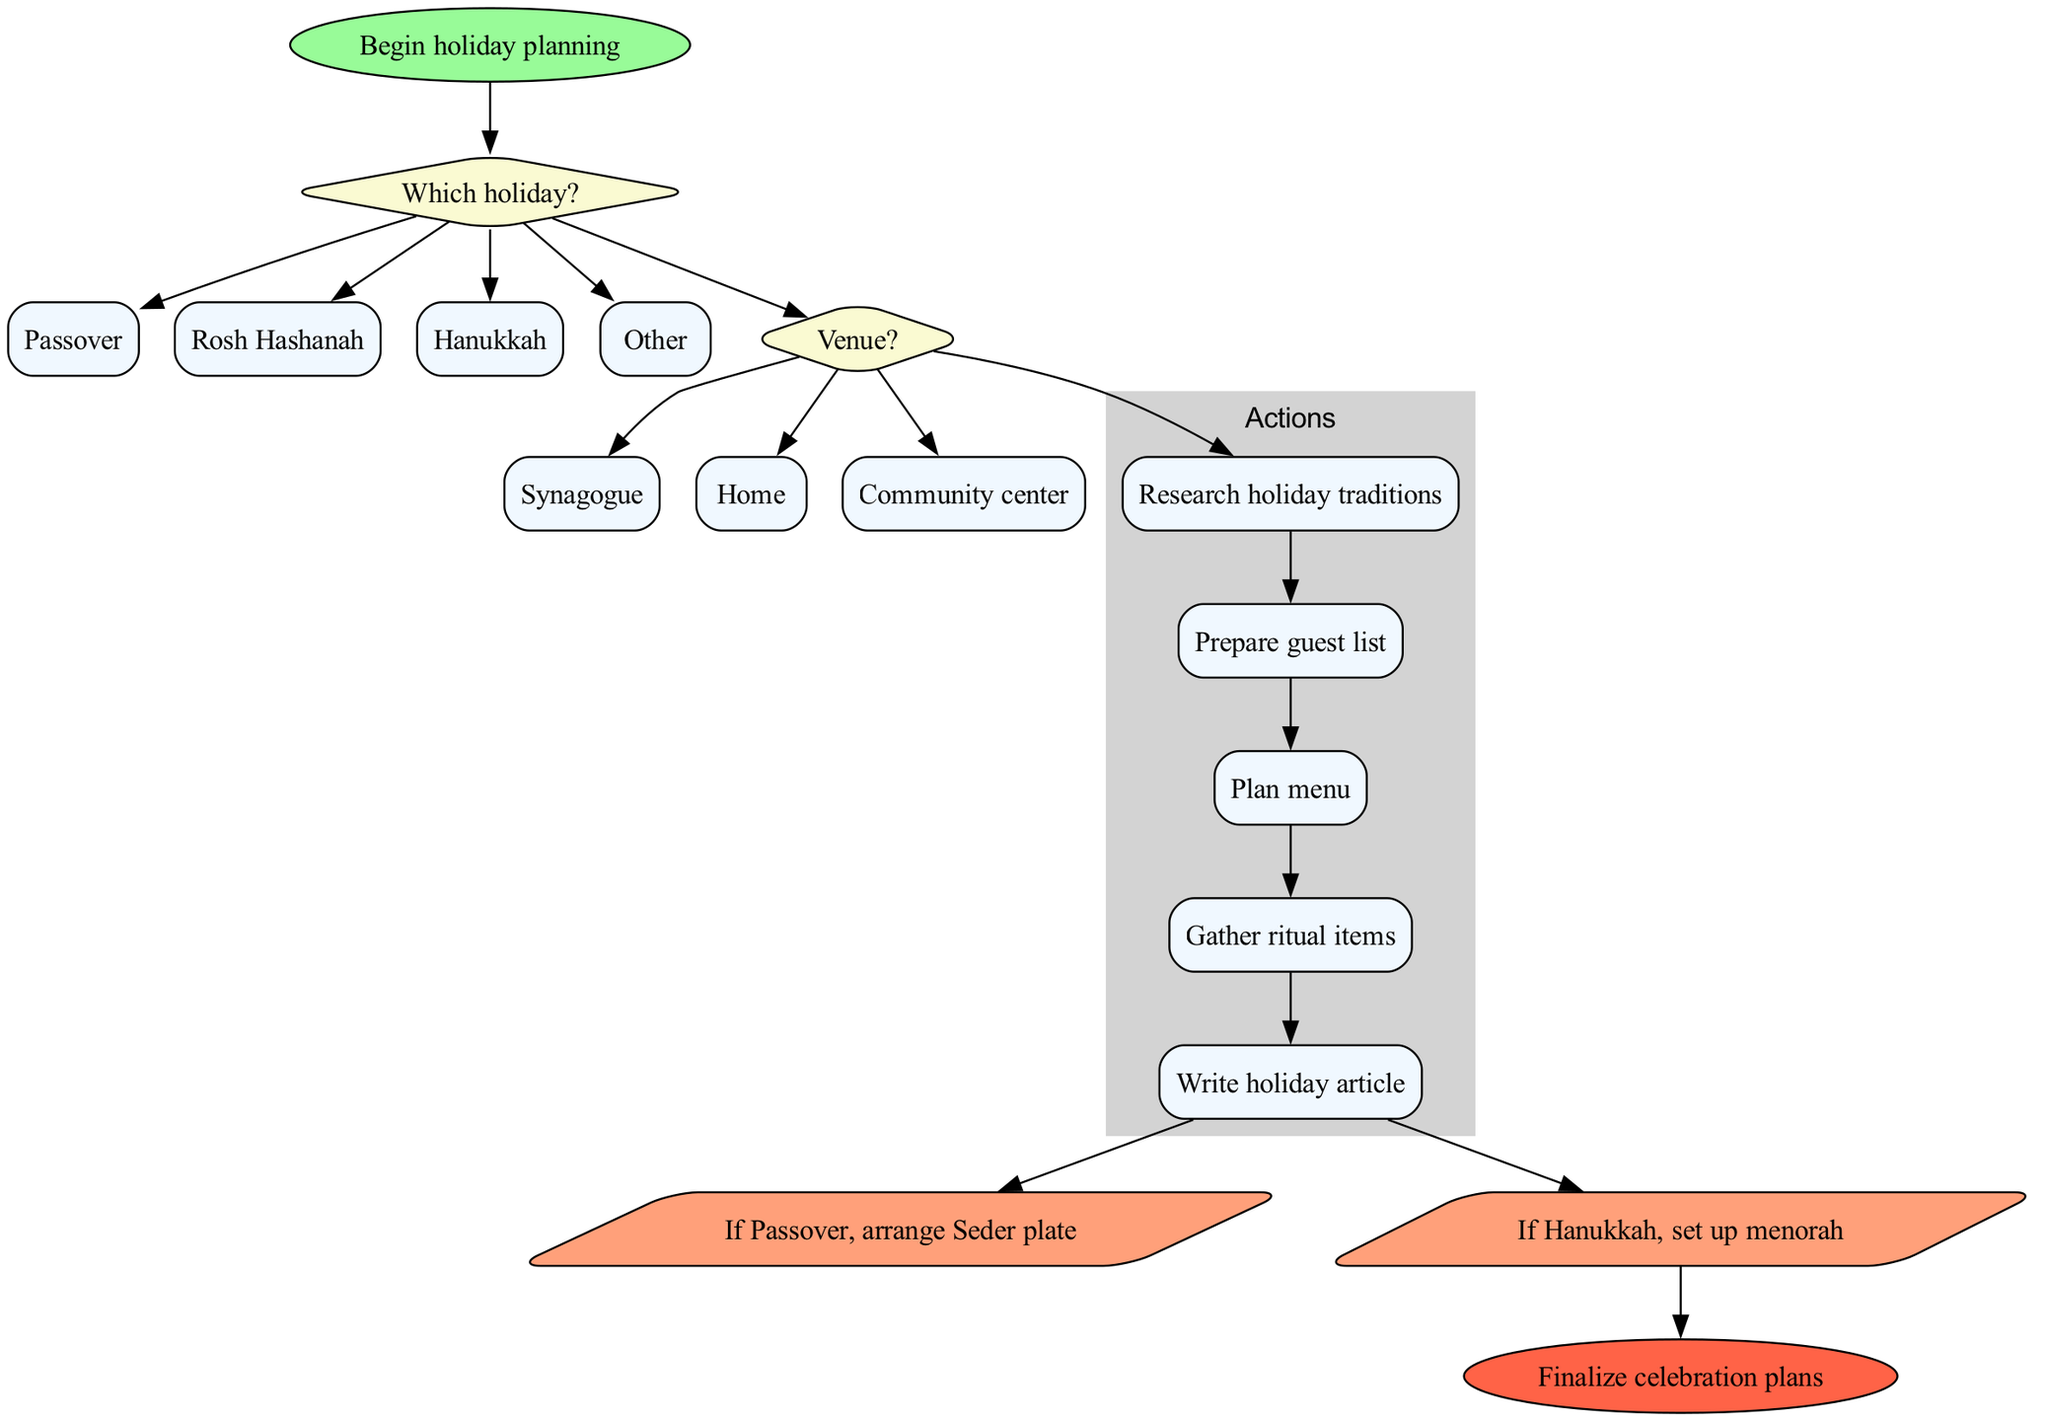What is the starting point of the diagram? The diagram begins at the node labeled "Begin holiday planning." This is the first node represented as the starting point of the flow chart.
Answer: Begin holiday planning How many holiday options are available in the decision node? There are four options listed in the decision node "Which holiday?" They are Passover, Rosh Hashanah, Hanukkah, and Other.
Answer: 4 What is the first action after making a decision about the holiday? After selecting a holiday, the first action as per the flow chart is "Research holiday traditions," connected to the last decision node.
Answer: Research holiday traditions Which venue option follows the decision about the holiday? The decision node asks for the venue after choosing a holiday. The options include Synagogue, Home, and Community center following after the holiday decision node.
Answer: Synagogue If Passover is chosen, what specific arrangement is needed? If Passover is selected in the flow chart, the specific arrangement needed is to "arrange Seder plate." It is a direct condition following from the action nodes and applies specifically to Passover.
Answer: Arrange Seder plate What happens after all actions are completed? Once all actions have been completed, the flow of the diagram directs to the condition nodes before finalization. Thus, the next step is reaching the end of the flow chart.
Answer: Finalize celebration plans How many conditions are listed in the flow chart? There are two conditions specified in the flow chart: "If Passover, arrange Seder plate" and "If Hanukkah, set up menorah" detailing what to do based on the holiday selected.
Answer: 2 What shape is used to represent conditions in this flow chart? Conditions in this flow chart are represented using a parallelogram shape, which is a standard convention for denoting conditions or decisions in flowcharts.
Answer: Parallelogram Which action directly precedes a specific condition? The action "Write holiday article" directly precedes the first condition "If Passover, arrange Seder plate," indicating a flow connection from completing actions to conditional checks.
Answer: Write holiday article 